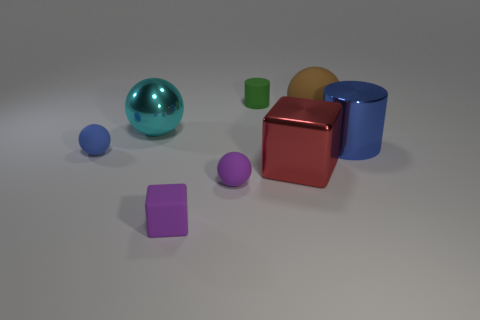Are there any other things of the same color as the matte cube?
Provide a short and direct response. Yes. There is a block to the left of the red thing; is it the same color as the large shiny block?
Provide a succinct answer. No. Is there another large metallic object of the same shape as the big brown thing?
Give a very brief answer. Yes. There is a block that is the same size as the green object; what color is it?
Keep it short and to the point. Purple. There is a metallic thing that is behind the large cylinder; what is its size?
Your response must be concise. Large. Is there a small blue matte sphere that is in front of the large sphere to the right of the big metallic block?
Ensure brevity in your answer.  Yes. Do the small ball that is behind the purple matte sphere and the green thing have the same material?
Give a very brief answer. Yes. What number of spheres are in front of the red thing and behind the purple matte sphere?
Offer a very short reply. 0. What number of tiny green things are the same material as the red object?
Your response must be concise. 0. There is a big cylinder that is made of the same material as the large block; what color is it?
Provide a succinct answer. Blue. 